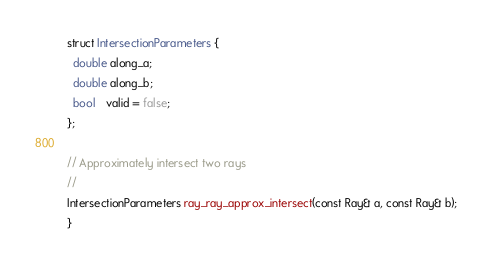Convert code to text. <code><loc_0><loc_0><loc_500><loc_500><_C++_>struct IntersectionParameters {
  double along_a;
  double along_b;
  bool   valid = false;
};

// Approximately intersect two rays
//
IntersectionParameters ray_ray_approx_intersect(const Ray& a, const Ray& b);
}</code> 